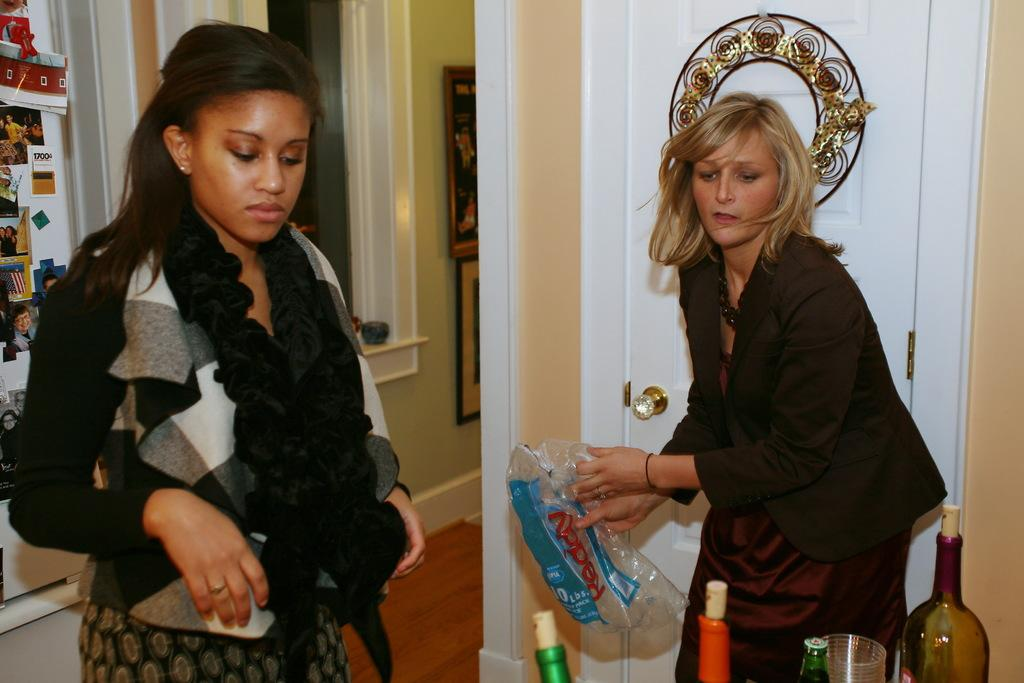How many women are present in the room in the image? There are two women standing in the room in the image. What can be seen on the wall in the image? There is a wall visible in the image, and frames are attached to it. What objects are related to drinking in the image? There is a bottle and a glass in the image. Can you see any snails crawling on the frames in the image? There are no snails visible in the image; the focus is on the women, the wall, and the objects related to drinking. 